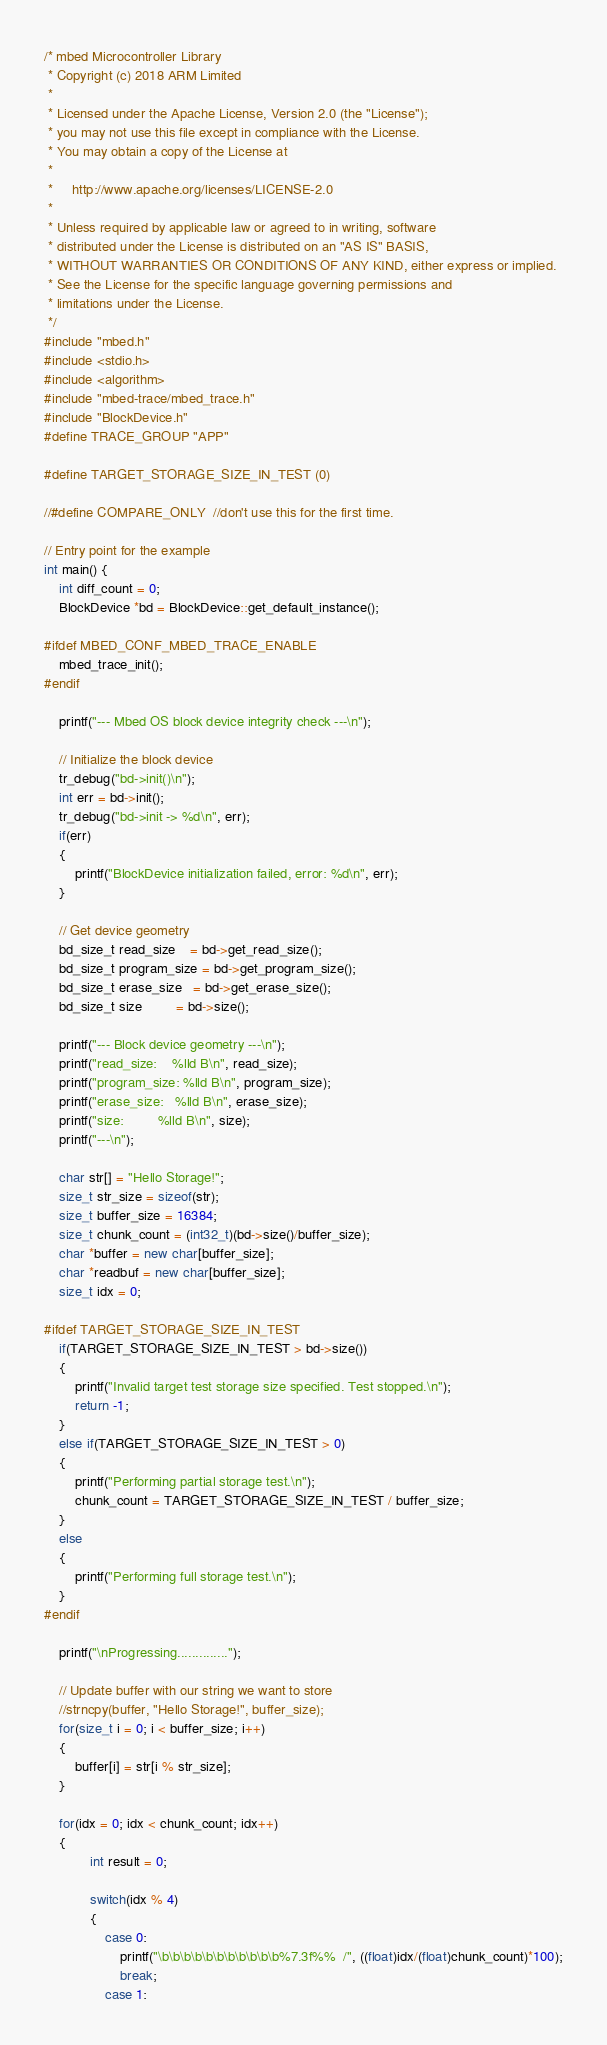<code> <loc_0><loc_0><loc_500><loc_500><_C++_>/* mbed Microcontroller Library
 * Copyright (c) 2018 ARM Limited
 *
 * Licensed under the Apache License, Version 2.0 (the "License");
 * you may not use this file except in compliance with the License.
 * You may obtain a copy of the License at
 *
 *     http://www.apache.org/licenses/LICENSE-2.0
 *
 * Unless required by applicable law or agreed to in writing, software
 * distributed under the License is distributed on an "AS IS" BASIS,
 * WITHOUT WARRANTIES OR CONDITIONS OF ANY KIND, either express or implied.
 * See the License for the specific language governing permissions and
 * limitations under the License.
 */
#include "mbed.h"
#include <stdio.h>
#include <algorithm>
#include "mbed-trace/mbed_trace.h"
#include "BlockDevice.h"
#define TRACE_GROUP "APP"

#define TARGET_STORAGE_SIZE_IN_TEST (0)

//#define COMPARE_ONLY  //don't use this for the first time.

// Entry point for the example
int main() {
    int diff_count = 0;
    BlockDevice *bd = BlockDevice::get_default_instance();

#ifdef MBED_CONF_MBED_TRACE_ENABLE
    mbed_trace_init();
#endif

    printf("--- Mbed OS block device integrity check ---\n");

    // Initialize the block device
    tr_debug("bd->init()\n");
    int err = bd->init();
    tr_debug("bd->init -> %d\n", err);
    if(err)
    {
        printf("BlockDevice initialization failed, error: %d\n", err);
    }

    // Get device geometry
    bd_size_t read_size    = bd->get_read_size();
    bd_size_t program_size = bd->get_program_size();
    bd_size_t erase_size   = bd->get_erase_size();
    bd_size_t size         = bd->size();

    printf("--- Block device geometry ---\n");
    printf("read_size:    %lld B\n", read_size);
    printf("program_size: %lld B\n", program_size);
    printf("erase_size:   %lld B\n", erase_size);
    printf("size:         %lld B\n", size);
    printf("---\n");

    char str[] = "Hello Storage!";
    size_t str_size = sizeof(str);
    size_t buffer_size = 16384;
    size_t chunk_count = (int32_t)(bd->size()/buffer_size);
    char *buffer = new char[buffer_size];
    char *readbuf = new char[buffer_size];
    size_t idx = 0;

#ifdef TARGET_STORAGE_SIZE_IN_TEST
    if(TARGET_STORAGE_SIZE_IN_TEST > bd->size())
    {
        printf("Invalid target test storage size specified. Test stopped.\n");
        return -1;
    }
    else if(TARGET_STORAGE_SIZE_IN_TEST > 0)
    {
        printf("Performing partial storage test.\n");
        chunk_count = TARGET_STORAGE_SIZE_IN_TEST / buffer_size;
    }
    else
    {
        printf("Performing full storage test.\n");
    }
#endif

    printf("\nProgressing..............");

    // Update buffer with our string we want to store
    //strncpy(buffer, "Hello Storage!", buffer_size);
    for(size_t i = 0; i < buffer_size; i++)
    {
        buffer[i] = str[i % str_size];
    }

    for(idx = 0; idx < chunk_count; idx++)
    {
            int result = 0;

            switch(idx % 4)
            {
                case 0:
                    printf("\b\b\b\b\b\b\b\b\b\b\b%7.3f%%  /", ((float)idx/(float)chunk_count)*100);
                    break;
                case 1:</code> 